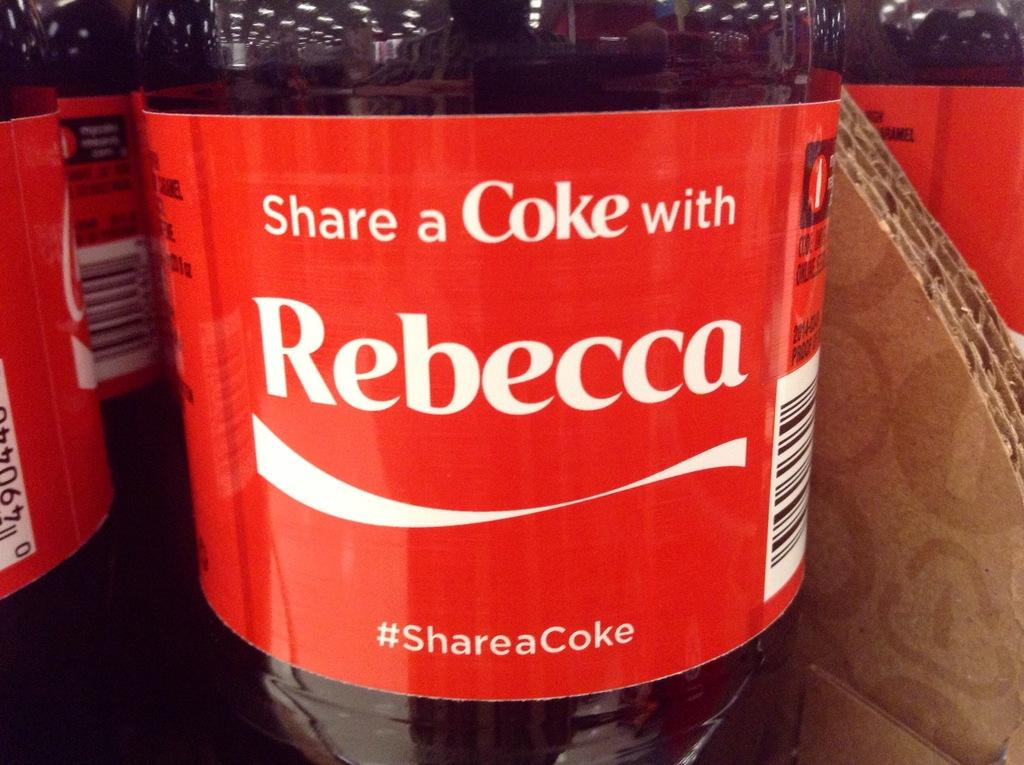<image>
Render a clear and concise summary of the photo. A bottle saying to share a Coke with Rebecca 